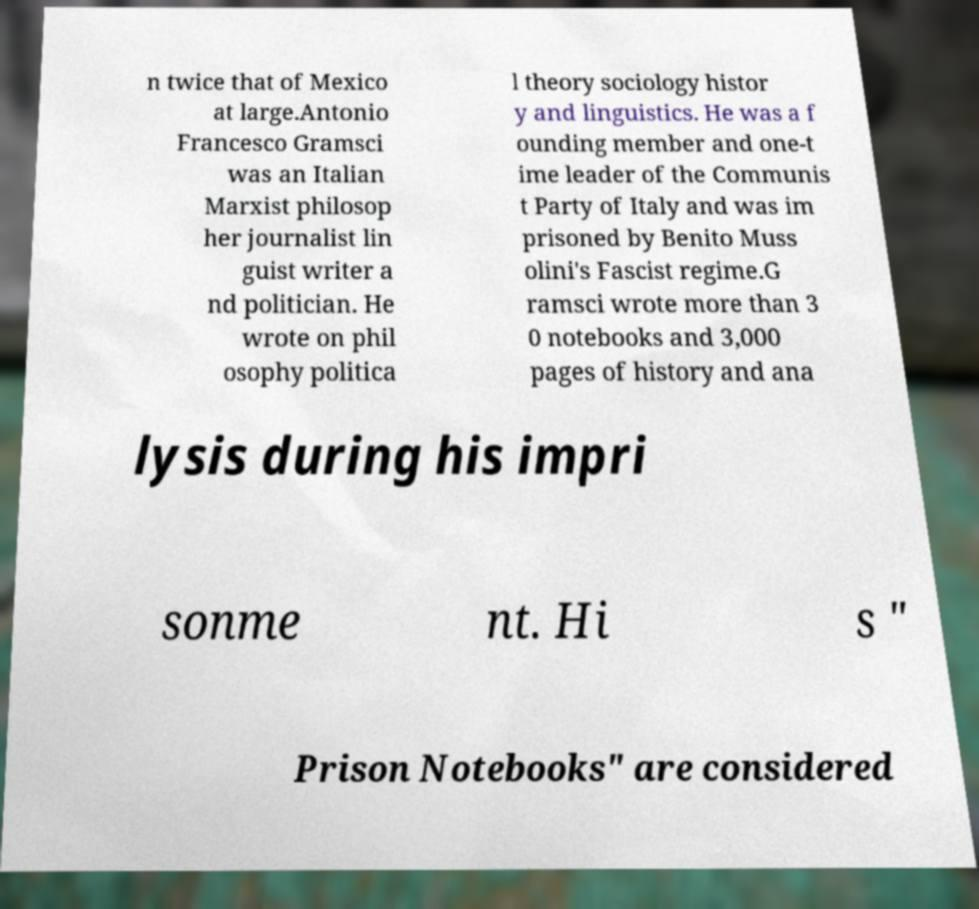Could you extract and type out the text from this image? n twice that of Mexico at large.Antonio Francesco Gramsci was an Italian Marxist philosop her journalist lin guist writer a nd politician. He wrote on phil osophy politica l theory sociology histor y and linguistics. He was a f ounding member and one-t ime leader of the Communis t Party of Italy and was im prisoned by Benito Muss olini's Fascist regime.G ramsci wrote more than 3 0 notebooks and 3,000 pages of history and ana lysis during his impri sonme nt. Hi s " Prison Notebooks" are considered 